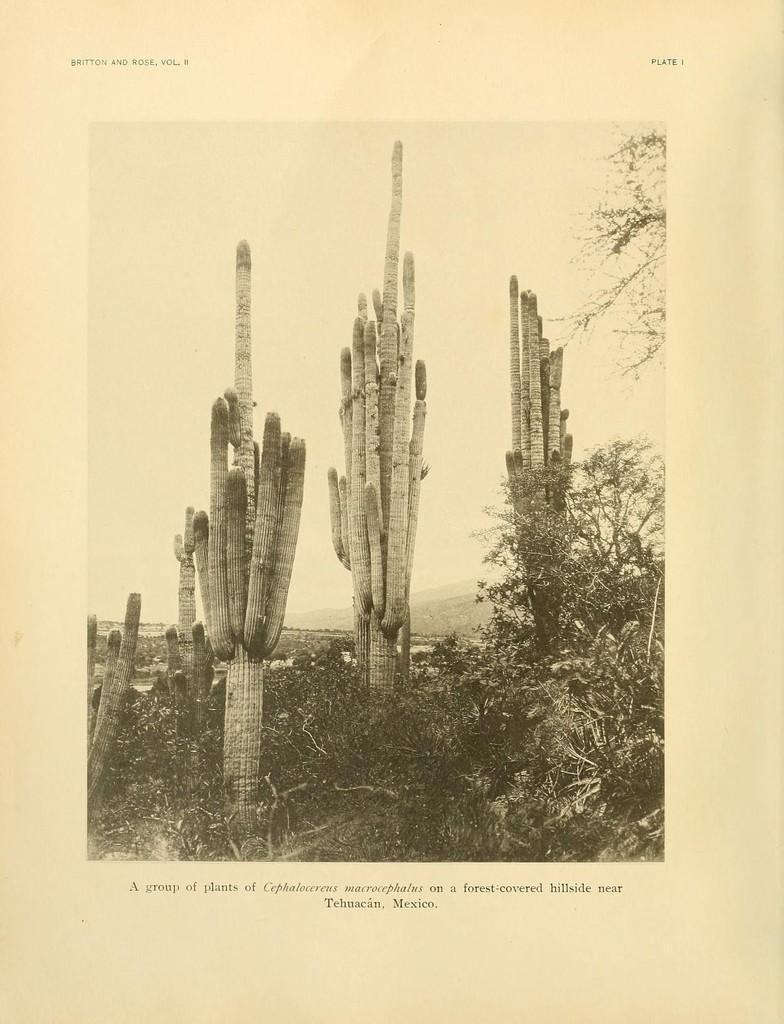What is depicted on the poster in the image? The poster contains an image. What can be seen in the image on the poster? The image has plants on the ground. What is visible in the background of the image on the poster? The background of the image includes trees, mountains, and clouds in the sky. What is the color of the text on the poster? The text on the poster is black in color. What type of soap is being compared to the plants in the image? There is no soap present in the image, and no comparison is being made between plants and soap. 